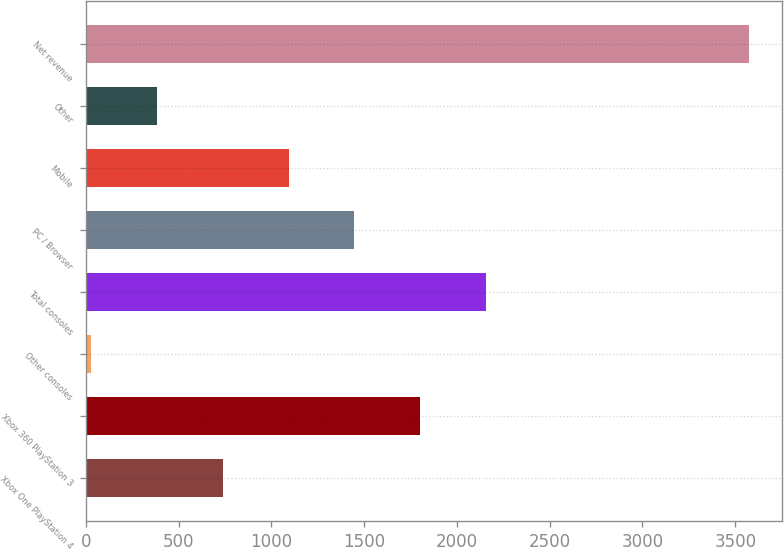Convert chart. <chart><loc_0><loc_0><loc_500><loc_500><bar_chart><fcel>Xbox One PlayStation 4<fcel>Xbox 360 PlayStation 3<fcel>Other consoles<fcel>Total consoles<fcel>PC / Browser<fcel>Mobile<fcel>Other<fcel>Net revenue<nl><fcel>739<fcel>1802.5<fcel>30<fcel>2157<fcel>1448<fcel>1093.5<fcel>384.5<fcel>3575<nl></chart> 